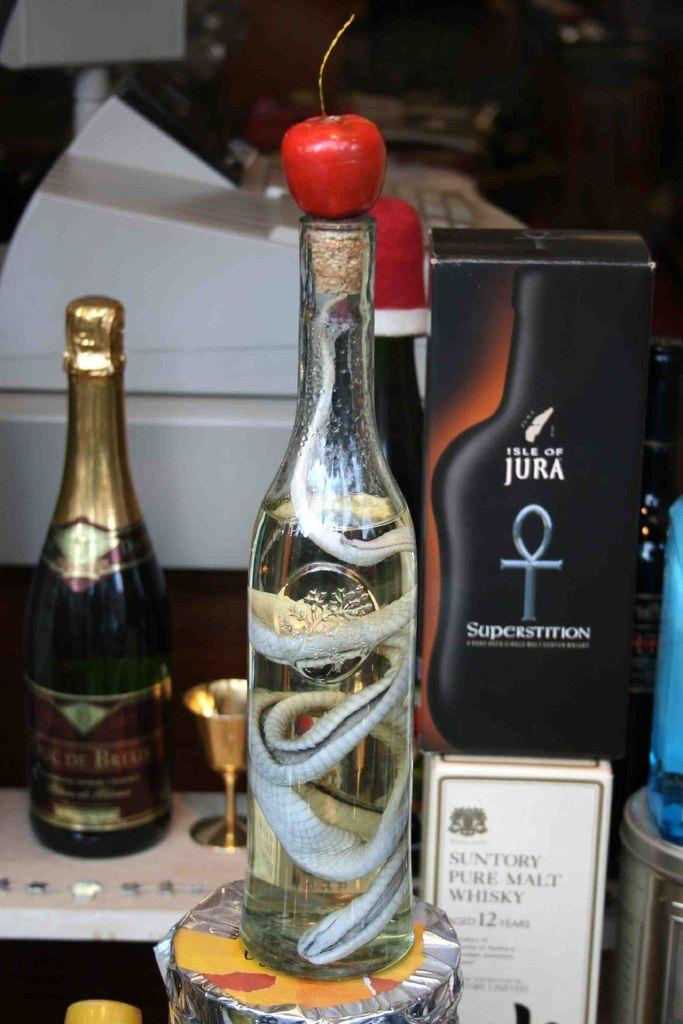<image>
Write a terse but informative summary of the picture. bottles of liquor on display including Isle of Jura 